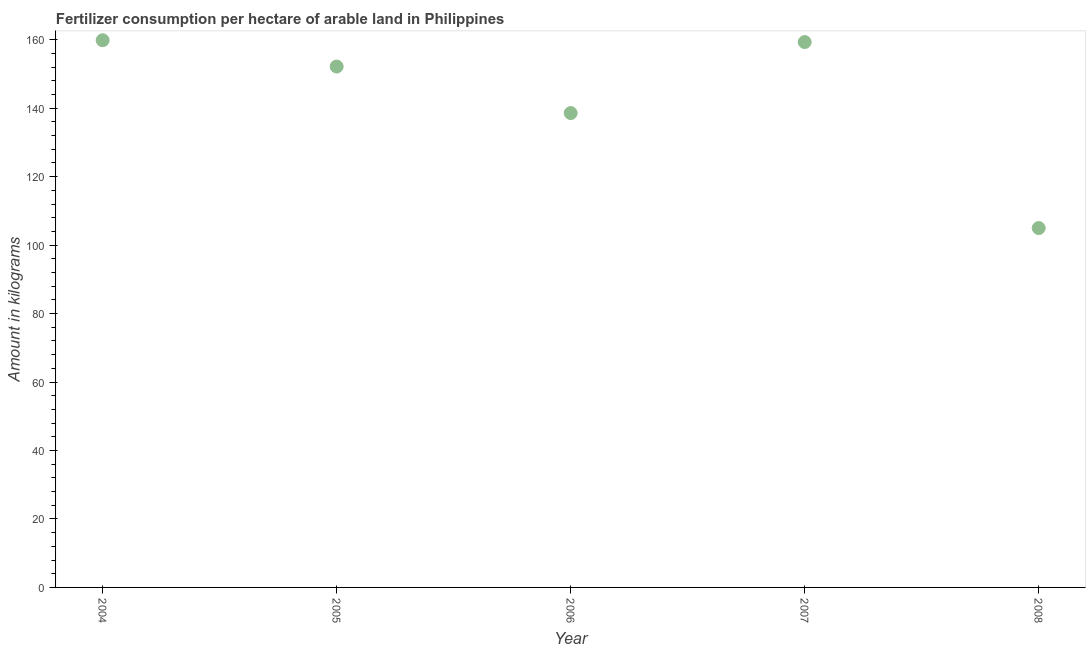What is the amount of fertilizer consumption in 2008?
Your response must be concise. 104.97. Across all years, what is the maximum amount of fertilizer consumption?
Keep it short and to the point. 159.85. Across all years, what is the minimum amount of fertilizer consumption?
Keep it short and to the point. 104.97. In which year was the amount of fertilizer consumption minimum?
Your answer should be compact. 2008. What is the sum of the amount of fertilizer consumption?
Your answer should be very brief. 714.84. What is the difference between the amount of fertilizer consumption in 2004 and 2005?
Your response must be concise. 7.69. What is the average amount of fertilizer consumption per year?
Provide a succinct answer. 142.97. What is the median amount of fertilizer consumption?
Provide a short and direct response. 152.16. In how many years, is the amount of fertilizer consumption greater than 92 kg?
Offer a very short reply. 5. What is the ratio of the amount of fertilizer consumption in 2004 to that in 2007?
Make the answer very short. 1. Is the amount of fertilizer consumption in 2006 less than that in 2007?
Ensure brevity in your answer.  Yes. What is the difference between the highest and the second highest amount of fertilizer consumption?
Give a very brief answer. 0.54. Is the sum of the amount of fertilizer consumption in 2005 and 2006 greater than the maximum amount of fertilizer consumption across all years?
Your answer should be very brief. Yes. What is the difference between the highest and the lowest amount of fertilizer consumption?
Offer a terse response. 54.87. In how many years, is the amount of fertilizer consumption greater than the average amount of fertilizer consumption taken over all years?
Keep it short and to the point. 3. Does the amount of fertilizer consumption monotonically increase over the years?
Your answer should be very brief. No. How many years are there in the graph?
Provide a short and direct response. 5. What is the difference between two consecutive major ticks on the Y-axis?
Give a very brief answer. 20. Does the graph contain any zero values?
Ensure brevity in your answer.  No. What is the title of the graph?
Offer a very short reply. Fertilizer consumption per hectare of arable land in Philippines . What is the label or title of the X-axis?
Offer a very short reply. Year. What is the label or title of the Y-axis?
Ensure brevity in your answer.  Amount in kilograms. What is the Amount in kilograms in 2004?
Your answer should be compact. 159.85. What is the Amount in kilograms in 2005?
Give a very brief answer. 152.16. What is the Amount in kilograms in 2006?
Offer a very short reply. 138.56. What is the Amount in kilograms in 2007?
Provide a succinct answer. 159.31. What is the Amount in kilograms in 2008?
Offer a very short reply. 104.97. What is the difference between the Amount in kilograms in 2004 and 2005?
Ensure brevity in your answer.  7.69. What is the difference between the Amount in kilograms in 2004 and 2006?
Your answer should be very brief. 21.28. What is the difference between the Amount in kilograms in 2004 and 2007?
Your response must be concise. 0.54. What is the difference between the Amount in kilograms in 2004 and 2008?
Provide a short and direct response. 54.87. What is the difference between the Amount in kilograms in 2005 and 2006?
Ensure brevity in your answer.  13.59. What is the difference between the Amount in kilograms in 2005 and 2007?
Ensure brevity in your answer.  -7.15. What is the difference between the Amount in kilograms in 2005 and 2008?
Ensure brevity in your answer.  47.18. What is the difference between the Amount in kilograms in 2006 and 2007?
Make the answer very short. -20.75. What is the difference between the Amount in kilograms in 2006 and 2008?
Offer a very short reply. 33.59. What is the difference between the Amount in kilograms in 2007 and 2008?
Your answer should be very brief. 54.34. What is the ratio of the Amount in kilograms in 2004 to that in 2005?
Provide a short and direct response. 1.05. What is the ratio of the Amount in kilograms in 2004 to that in 2006?
Offer a terse response. 1.15. What is the ratio of the Amount in kilograms in 2004 to that in 2007?
Your answer should be very brief. 1. What is the ratio of the Amount in kilograms in 2004 to that in 2008?
Your answer should be compact. 1.52. What is the ratio of the Amount in kilograms in 2005 to that in 2006?
Give a very brief answer. 1.1. What is the ratio of the Amount in kilograms in 2005 to that in 2007?
Offer a terse response. 0.95. What is the ratio of the Amount in kilograms in 2005 to that in 2008?
Make the answer very short. 1.45. What is the ratio of the Amount in kilograms in 2006 to that in 2007?
Make the answer very short. 0.87. What is the ratio of the Amount in kilograms in 2006 to that in 2008?
Your answer should be very brief. 1.32. What is the ratio of the Amount in kilograms in 2007 to that in 2008?
Make the answer very short. 1.52. 